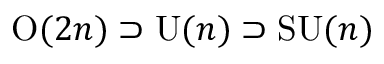<formula> <loc_0><loc_0><loc_500><loc_500>O ( 2 n ) \supset U ( n ) \supset S U ( n )</formula> 